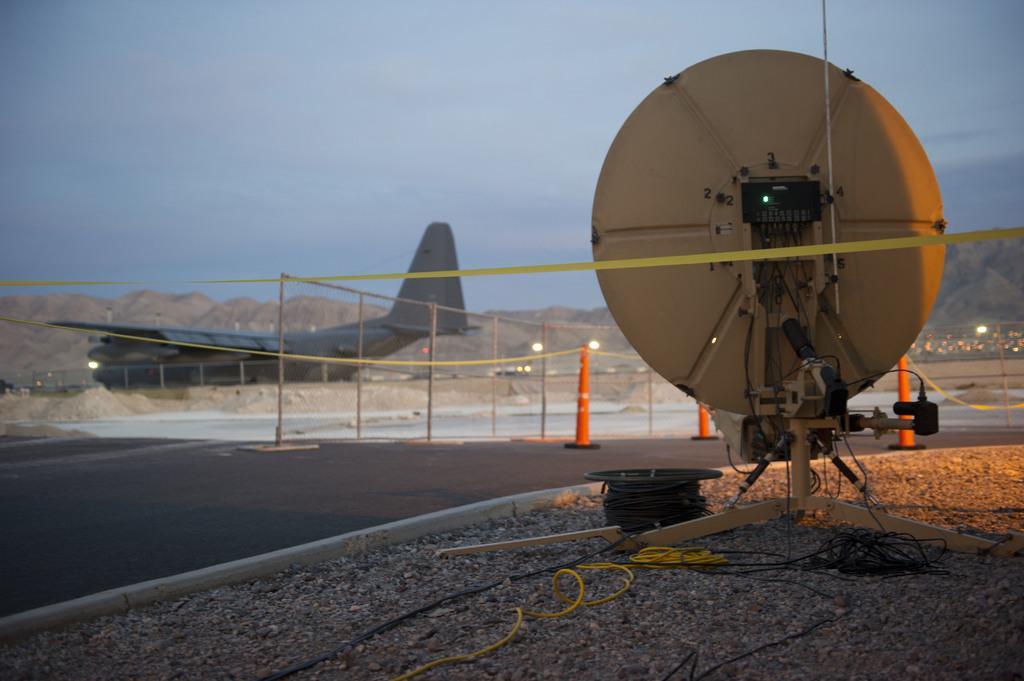Can you describe this image briefly? In the left side there is an aeroplane which is in grey color, here it is a road. At the top it's a sky. 